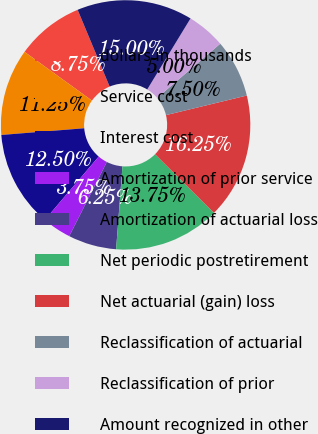<chart> <loc_0><loc_0><loc_500><loc_500><pie_chart><fcel>dollars in thousands<fcel>Service cost<fcel>Interest cost<fcel>Amortization of prior service<fcel>Amortization of actuarial loss<fcel>Net periodic postretirement<fcel>Net actuarial (gain) loss<fcel>Reclassification of actuarial<fcel>Reclassification of prior<fcel>Amount recognized in other<nl><fcel>8.75%<fcel>11.25%<fcel>12.5%<fcel>3.75%<fcel>6.25%<fcel>13.75%<fcel>16.25%<fcel>7.5%<fcel>5.0%<fcel>15.0%<nl></chart> 